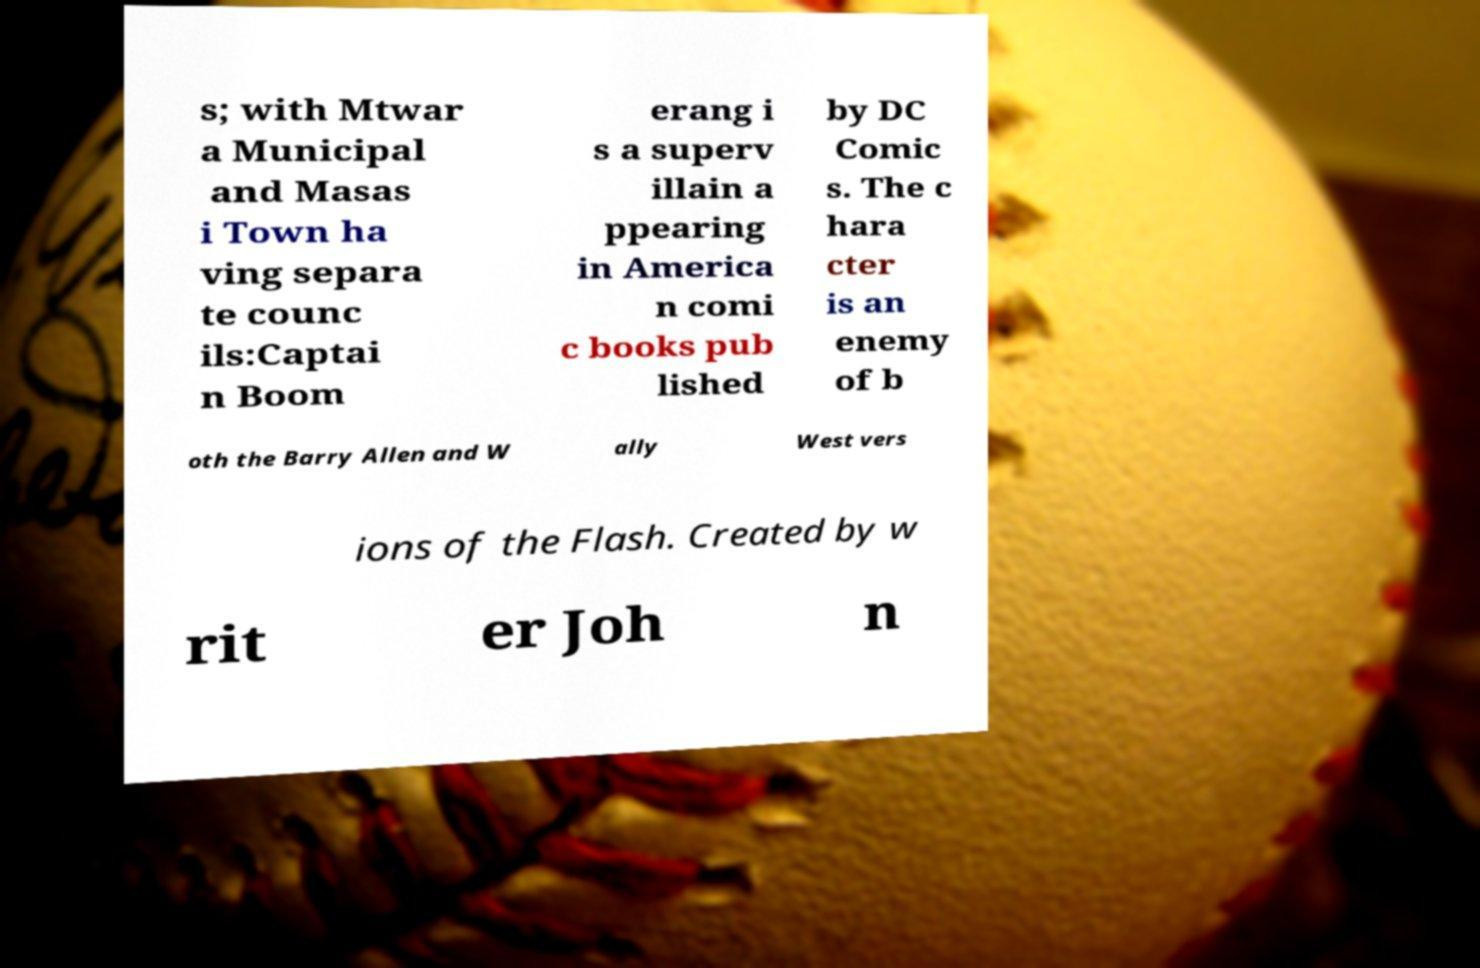Can you read and provide the text displayed in the image?This photo seems to have some interesting text. Can you extract and type it out for me? s; with Mtwar a Municipal and Masas i Town ha ving separa te counc ils:Captai n Boom erang i s a superv illain a ppearing in America n comi c books pub lished by DC Comic s. The c hara cter is an enemy of b oth the Barry Allen and W ally West vers ions of the Flash. Created by w rit er Joh n 